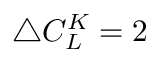<formula> <loc_0><loc_0><loc_500><loc_500>\bigtriangleup C _ { L } ^ { K } = 2</formula> 